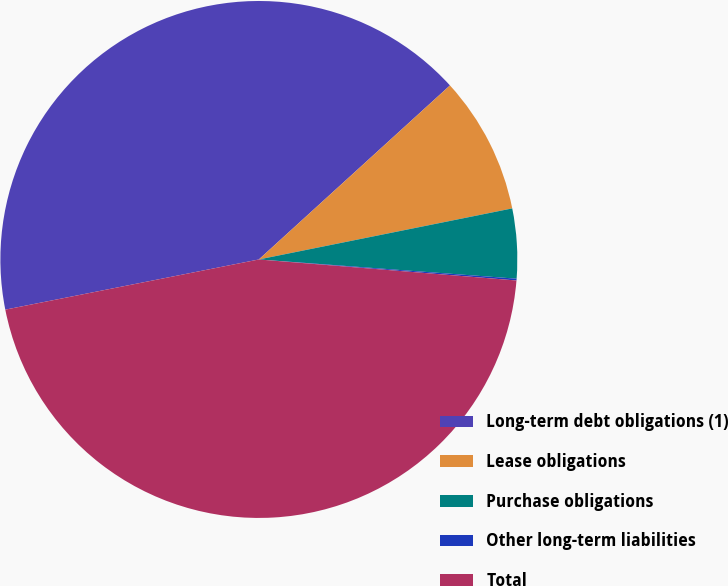Convert chart to OTSL. <chart><loc_0><loc_0><loc_500><loc_500><pie_chart><fcel>Long-term debt obligations (1)<fcel>Lease obligations<fcel>Purchase obligations<fcel>Other long-term liabilities<fcel>Total<nl><fcel>41.35%<fcel>8.59%<fcel>4.35%<fcel>0.11%<fcel>45.59%<nl></chart> 